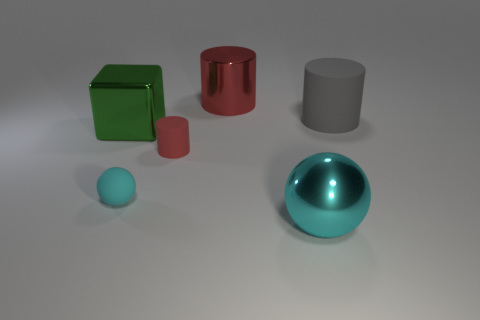The shiny sphere that is the same size as the green metal thing is what color?
Your answer should be very brief. Cyan. Are the small red object and the gray object made of the same material?
Keep it short and to the point. Yes. What number of big cylinders are the same color as the tiny matte cylinder?
Your answer should be very brief. 1. Do the tiny cylinder and the metallic cylinder have the same color?
Your answer should be very brief. Yes. There is a red cylinder that is in front of the gray matte cylinder; what material is it?
Your answer should be very brief. Rubber. What number of large things are either green shiny things or matte things?
Provide a succinct answer. 2. There is a tiny object that is the same color as the large metal sphere; what is its material?
Make the answer very short. Rubber. Is there a small cyan ball made of the same material as the green block?
Your response must be concise. No. Does the cyan object that is behind the metal ball have the same size as the large cyan object?
Your response must be concise. No. There is a matte cylinder on the left side of the thing that is behind the big gray matte thing; are there any tiny rubber spheres that are behind it?
Your response must be concise. No. 